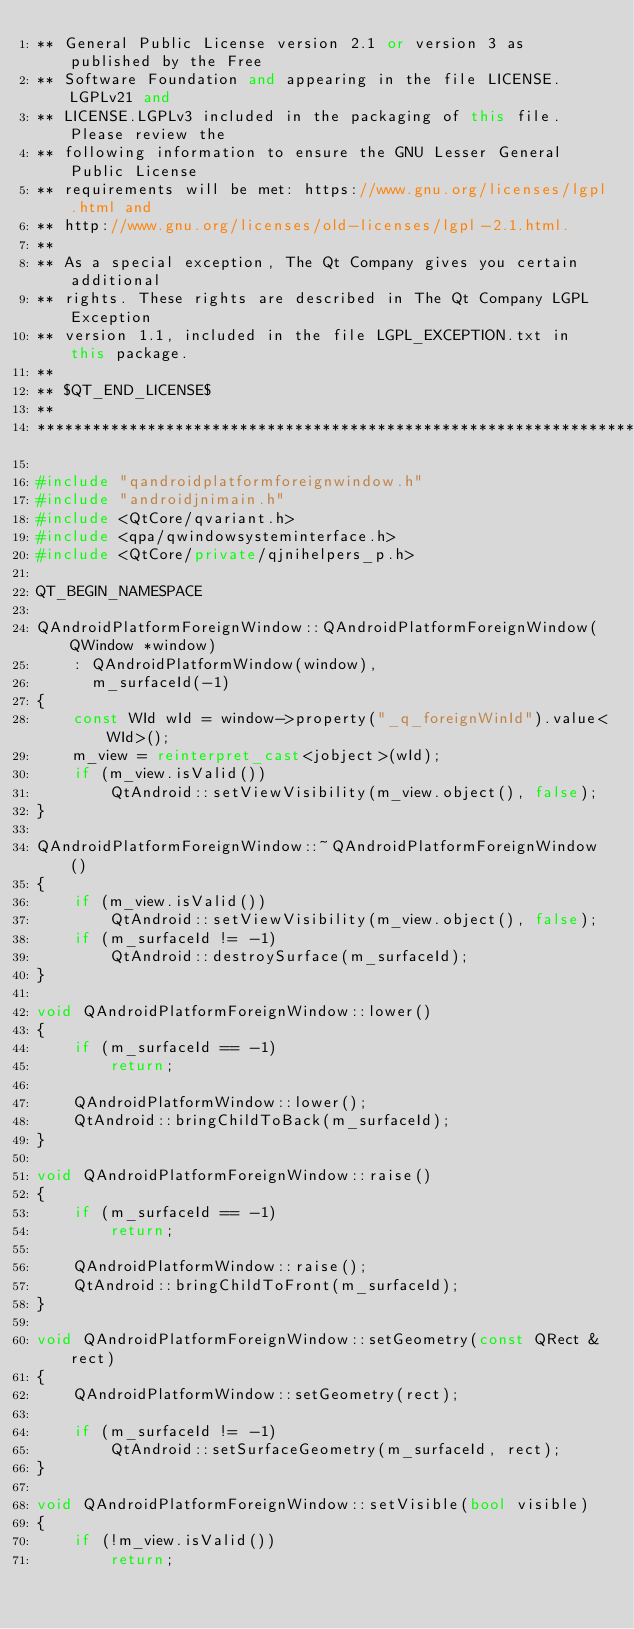Convert code to text. <code><loc_0><loc_0><loc_500><loc_500><_C++_>** General Public License version 2.1 or version 3 as published by the Free
** Software Foundation and appearing in the file LICENSE.LGPLv21 and
** LICENSE.LGPLv3 included in the packaging of this file. Please review the
** following information to ensure the GNU Lesser General Public License
** requirements will be met: https://www.gnu.org/licenses/lgpl.html and
** http://www.gnu.org/licenses/old-licenses/lgpl-2.1.html.
**
** As a special exception, The Qt Company gives you certain additional
** rights. These rights are described in The Qt Company LGPL Exception
** version 1.1, included in the file LGPL_EXCEPTION.txt in this package.
**
** $QT_END_LICENSE$
**
****************************************************************************/

#include "qandroidplatformforeignwindow.h"
#include "androidjnimain.h"
#include <QtCore/qvariant.h>
#include <qpa/qwindowsysteminterface.h>
#include <QtCore/private/qjnihelpers_p.h>

QT_BEGIN_NAMESPACE

QAndroidPlatformForeignWindow::QAndroidPlatformForeignWindow(QWindow *window)
    : QAndroidPlatformWindow(window),
      m_surfaceId(-1)
{
    const WId wId = window->property("_q_foreignWinId").value<WId>();
    m_view = reinterpret_cast<jobject>(wId);
    if (m_view.isValid())
        QtAndroid::setViewVisibility(m_view.object(), false);
}

QAndroidPlatformForeignWindow::~QAndroidPlatformForeignWindow()
{
    if (m_view.isValid())
        QtAndroid::setViewVisibility(m_view.object(), false);
    if (m_surfaceId != -1)
        QtAndroid::destroySurface(m_surfaceId);
}

void QAndroidPlatformForeignWindow::lower()
{
    if (m_surfaceId == -1)
        return;

    QAndroidPlatformWindow::lower();
    QtAndroid::bringChildToBack(m_surfaceId);
}

void QAndroidPlatformForeignWindow::raise()
{
    if (m_surfaceId == -1)
        return;

    QAndroidPlatformWindow::raise();
    QtAndroid::bringChildToFront(m_surfaceId);
}

void QAndroidPlatformForeignWindow::setGeometry(const QRect &rect)
{
    QAndroidPlatformWindow::setGeometry(rect);

    if (m_surfaceId != -1)
        QtAndroid::setSurfaceGeometry(m_surfaceId, rect);
}

void QAndroidPlatformForeignWindow::setVisible(bool visible)
{
    if (!m_view.isValid())
        return;
</code> 